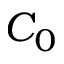Convert formula to latex. <formula><loc_0><loc_0><loc_500><loc_500>C _ { 0 }</formula> 